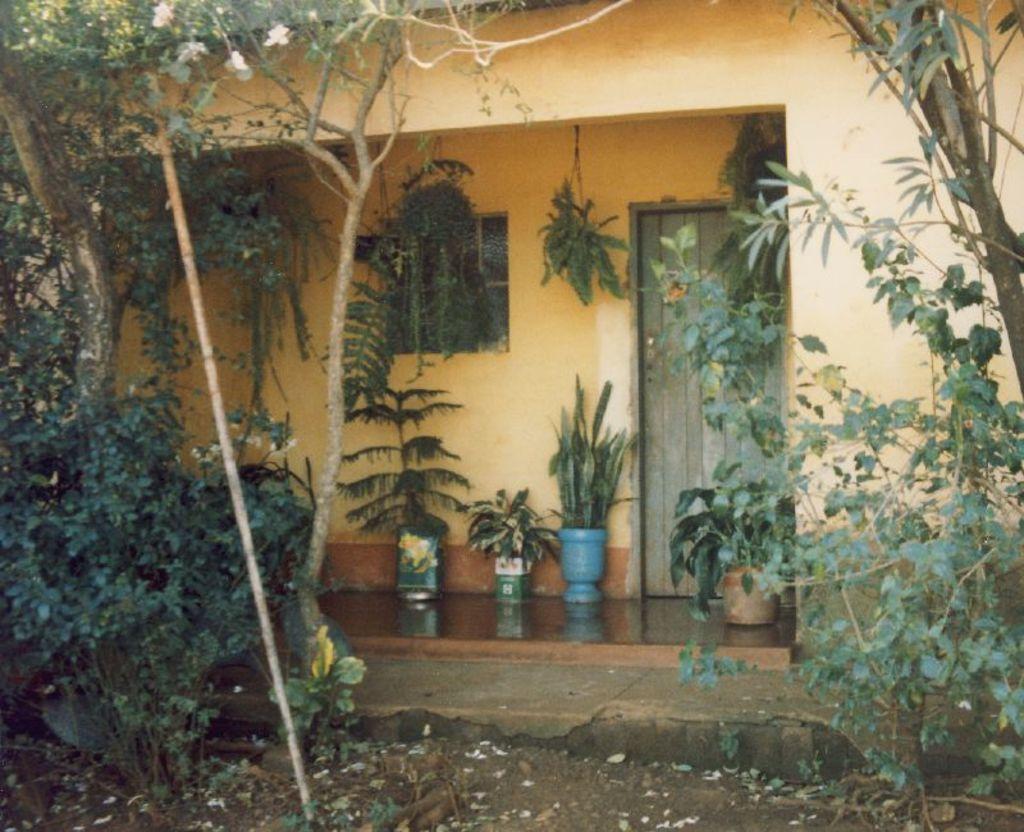In one or two sentences, can you explain what this image depicts? In this picture we can see a building, on the right side and left side there are trees, we can see some plants in the middle, at the bottom there are some leaves. 